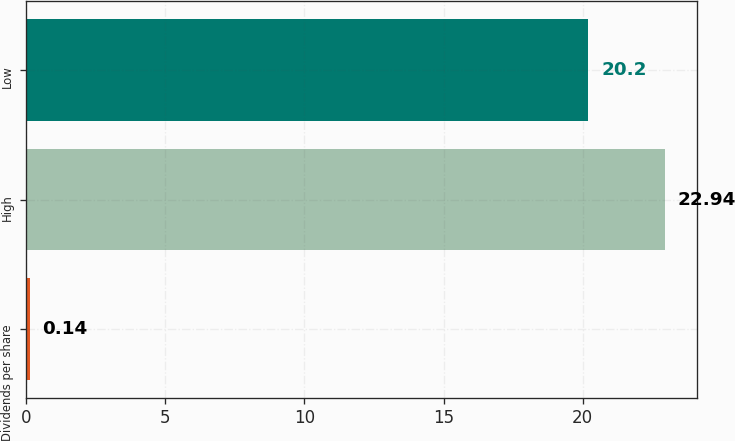Convert chart to OTSL. <chart><loc_0><loc_0><loc_500><loc_500><bar_chart><fcel>Dividends per share<fcel>High<fcel>Low<nl><fcel>0.14<fcel>22.94<fcel>20.2<nl></chart> 